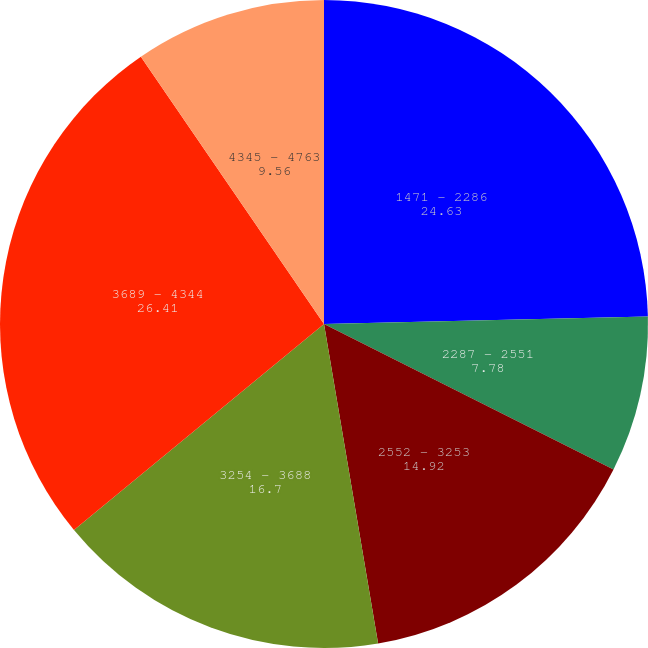Convert chart to OTSL. <chart><loc_0><loc_0><loc_500><loc_500><pie_chart><fcel>1471 - 2286<fcel>2287 - 2551<fcel>2552 - 3253<fcel>3254 - 3688<fcel>3689 - 4344<fcel>4345 - 4763<nl><fcel>24.63%<fcel>7.78%<fcel>14.92%<fcel>16.7%<fcel>26.41%<fcel>9.56%<nl></chart> 